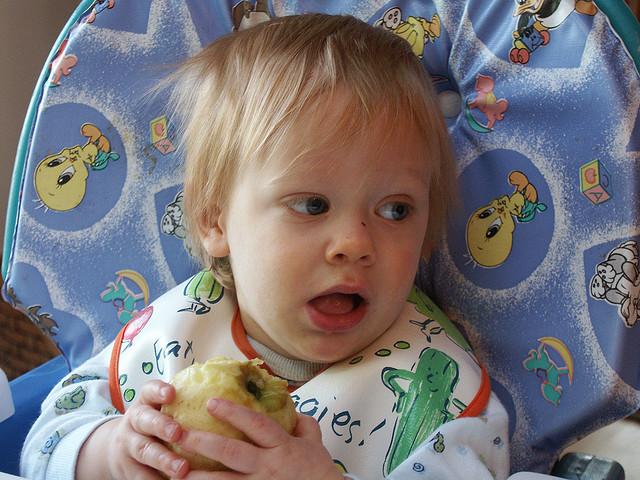What object is on the child's bib?
Give a very brief answer. Veggies. Is the baby eating apple?
Give a very brief answer. Yes. What cartoon characters are on the high chair cover?
Concise answer only. Tweety bird. What protects the baby's clothes from getting stained with food?
Be succinct. Bib. 